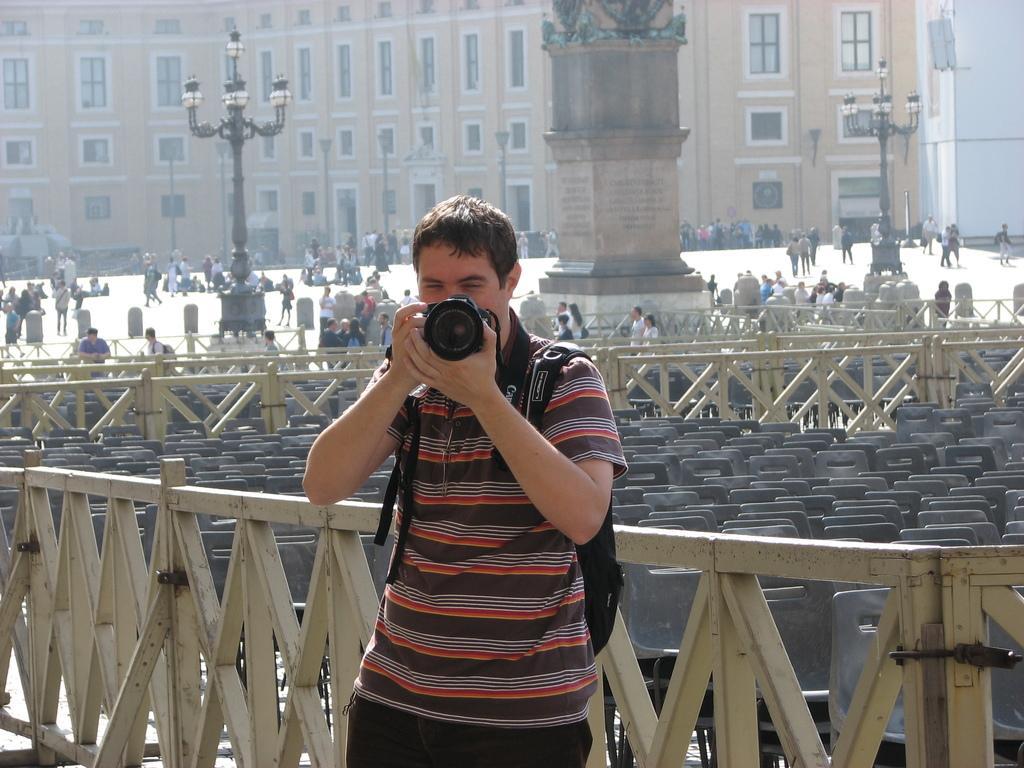Describe this image in one or two sentences. In this image we can see one building, one statue with pillar, some text on the statue pillar, some lights with poles, one banner near the building, one board with text attached to the wall, three objects on the top right side corner of the image, some people sitting on the ground, some fences, some people are standing, some chairs, some people are walking, some people are wearing bags, some people are holding objects, some objects on the ground, one object looks like vehicle on the left side of the image, one man standing, wearing a bag and holding camera in the middle of the image. 